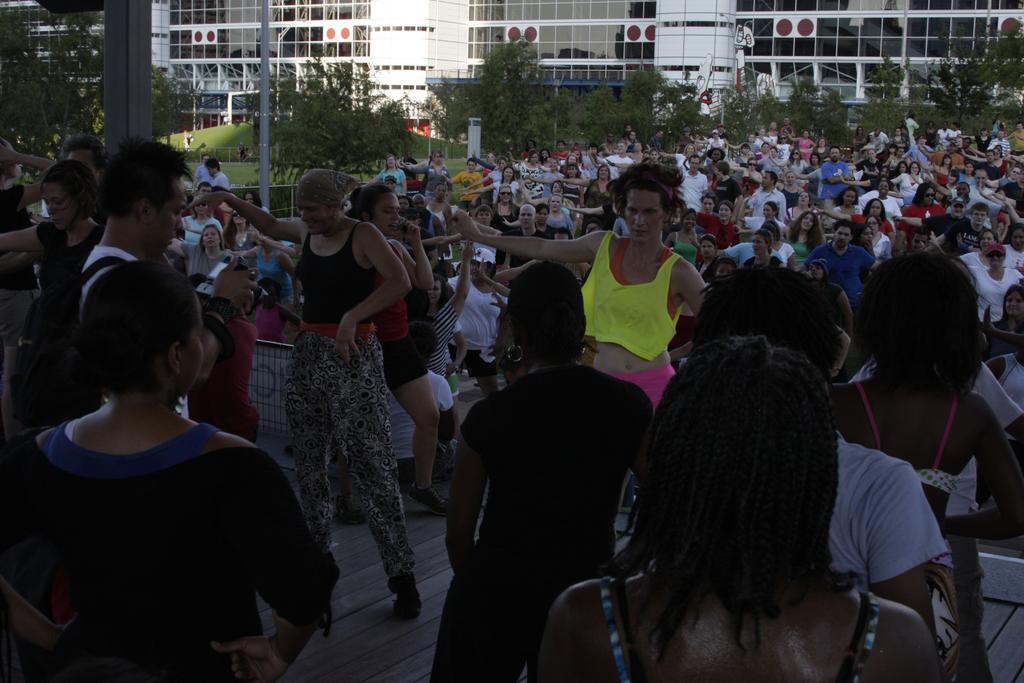How many people are in the image? There is a group of people in the image. What type of structures can be seen in the image? There are buildings in the image. What type of vegetation is present in the image? Trees are present in the image. What type of vertical structures can be seen in the image? Poles are visible in the image. What type of barrier is present in the image? Fencing is present in the image. What type of ground cover is visible in the image? Grass is visible in the image. What type of home can be seen in the image? There is no home present in the image; only a group of people, buildings, trees, poles, fencing, and grass are visible. What type of laborer is working on the fencing in the image? There is no laborer present in the image, nor is there any indication of work being done on the fencing. 